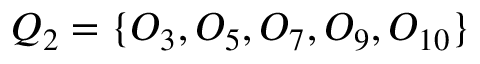Convert formula to latex. <formula><loc_0><loc_0><loc_500><loc_500>Q _ { 2 } = \{ O _ { 3 } , O _ { 5 } , O _ { 7 } , O _ { 9 } , O _ { 1 0 } \}</formula> 